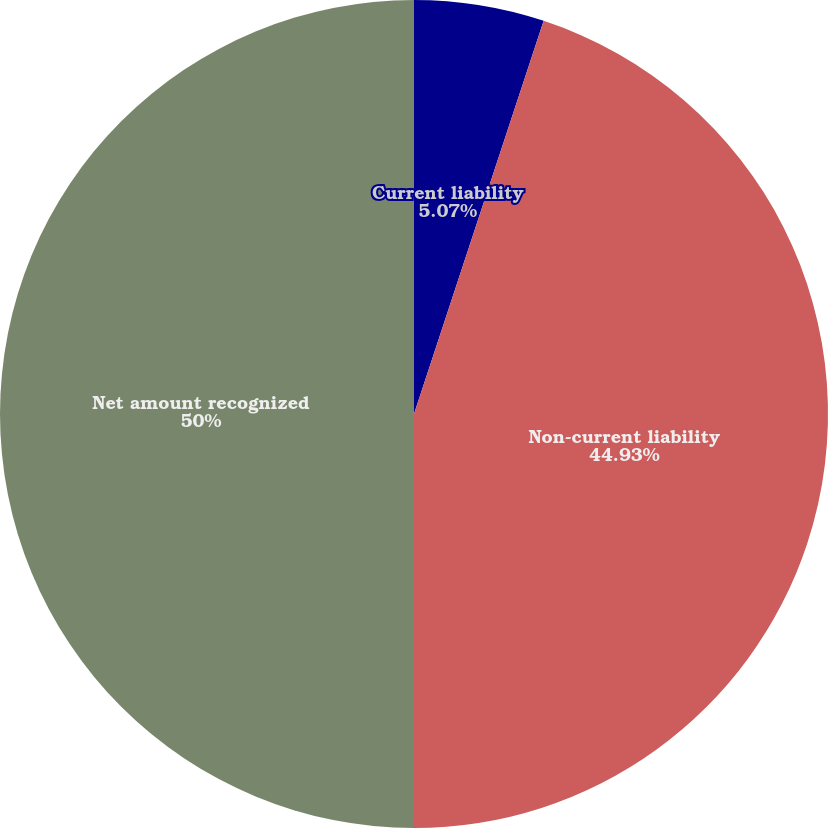Convert chart to OTSL. <chart><loc_0><loc_0><loc_500><loc_500><pie_chart><fcel>Current liability<fcel>Non-current liability<fcel>Net amount recognized<nl><fcel>5.07%<fcel>44.93%<fcel>50.0%<nl></chart> 